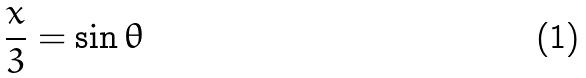<formula> <loc_0><loc_0><loc_500><loc_500>\frac { x } { 3 } = \sin \theta</formula> 